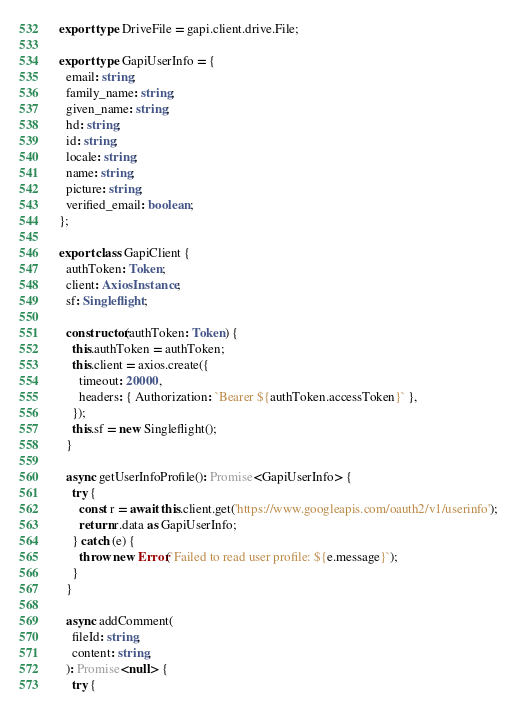<code> <loc_0><loc_0><loc_500><loc_500><_TypeScript_>
export type DriveFile = gapi.client.drive.File;

export type GapiUserInfo = {
  email: string;
  family_name: string;
  given_name: string;
  hd: string;
  id: string;
  locale: string;
  name: string;
  picture: string;
  verified_email: boolean;
};

export class GapiClient {
  authToken: Token;
  client: AxiosInstance;
  sf: Singleflight;

  constructor(authToken: Token) {
    this.authToken = authToken;
    this.client = axios.create({
      timeout: 20000,
      headers: { Authorization: `Bearer ${authToken.accessToken}` },
    });
    this.sf = new Singleflight();
  }

  async getUserInfoProfile(): Promise<GapiUserInfo> {
    try {
      const r = await this.client.get('https://www.googleapis.com/oauth2/v1/userinfo');
      return r.data as GapiUserInfo;
    } catch (e) {
      throw new Error(`Failed to read user profile: ${e.message}`);
    }
  }

  async addComment(
    fileId: string,
    content: string,
  ): Promise<null> {
    try {</code> 